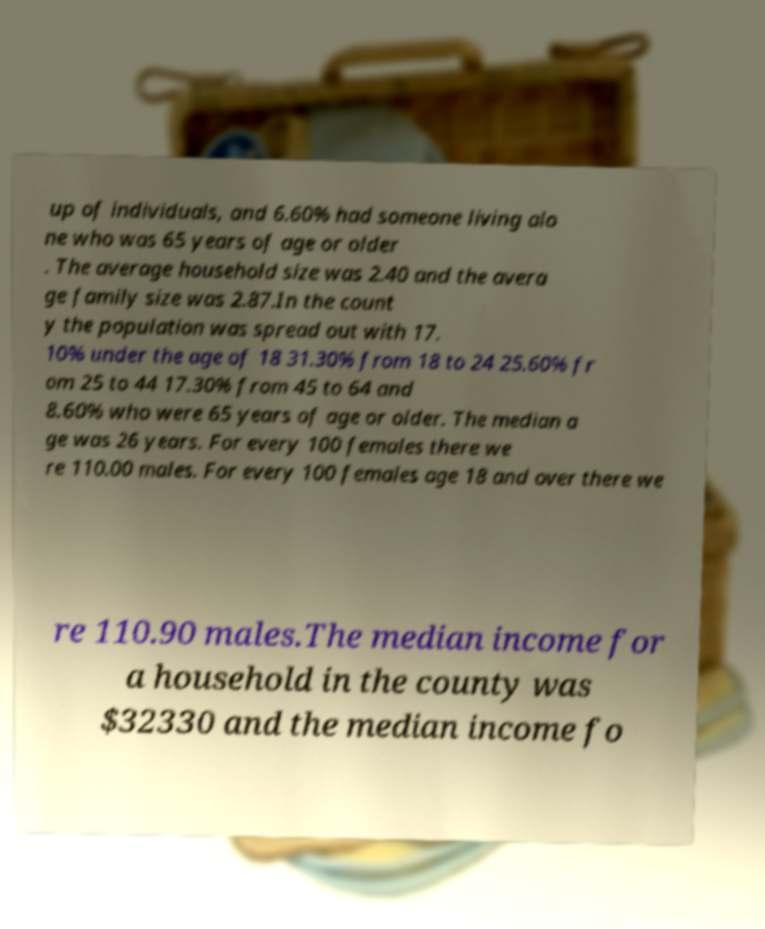Could you extract and type out the text from this image? up of individuals, and 6.60% had someone living alo ne who was 65 years of age or older . The average household size was 2.40 and the avera ge family size was 2.87.In the count y the population was spread out with 17. 10% under the age of 18 31.30% from 18 to 24 25.60% fr om 25 to 44 17.30% from 45 to 64 and 8.60% who were 65 years of age or older. The median a ge was 26 years. For every 100 females there we re 110.00 males. For every 100 females age 18 and over there we re 110.90 males.The median income for a household in the county was $32330 and the median income fo 